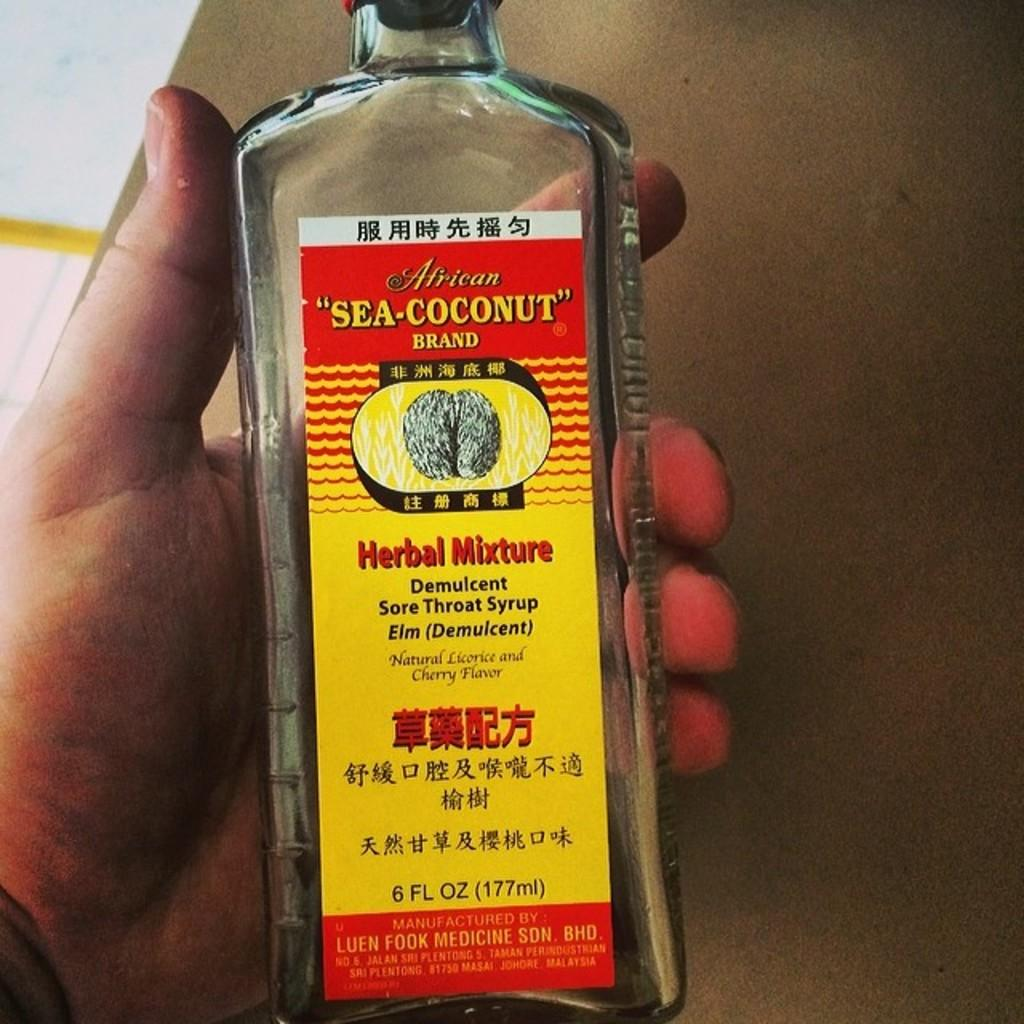<image>
Create a compact narrative representing the image presented. The label on a bottle claims to be a herbal mixture sore throat syrup. 